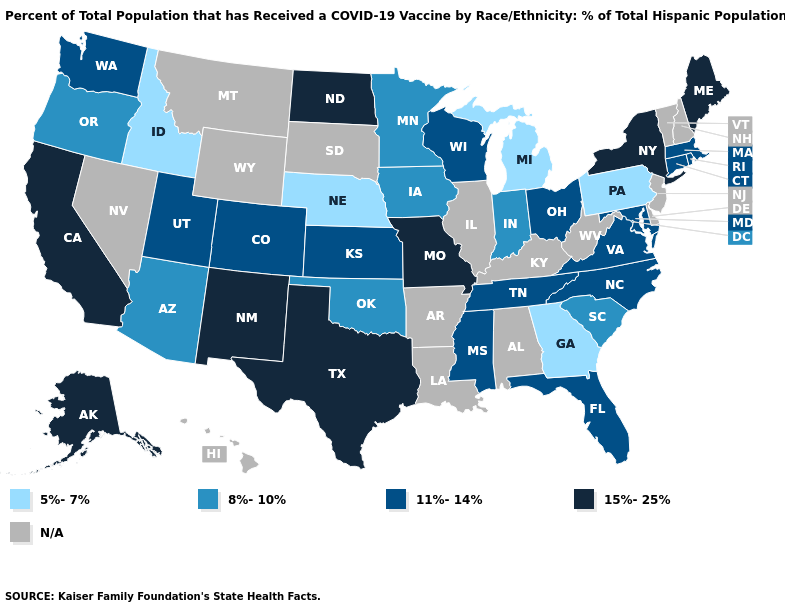What is the lowest value in the USA?
Concise answer only. 5%-7%. What is the lowest value in the USA?
Give a very brief answer. 5%-7%. What is the value of Arkansas?
Answer briefly. N/A. Name the states that have a value in the range 8%-10%?
Write a very short answer. Arizona, Indiana, Iowa, Minnesota, Oklahoma, Oregon, South Carolina. What is the value of New Jersey?
Give a very brief answer. N/A. What is the value of South Dakota?
Concise answer only. N/A. What is the value of Hawaii?
Quick response, please. N/A. What is the highest value in states that border Utah?
Give a very brief answer. 15%-25%. Does North Dakota have the highest value in the MidWest?
Quick response, please. Yes. What is the highest value in states that border Nevada?
Give a very brief answer. 15%-25%. What is the lowest value in the South?
Short answer required. 5%-7%. What is the value of South Dakota?
Write a very short answer. N/A. Name the states that have a value in the range 11%-14%?
Be succinct. Colorado, Connecticut, Florida, Kansas, Maryland, Massachusetts, Mississippi, North Carolina, Ohio, Rhode Island, Tennessee, Utah, Virginia, Washington, Wisconsin. What is the value of West Virginia?
Answer briefly. N/A. 